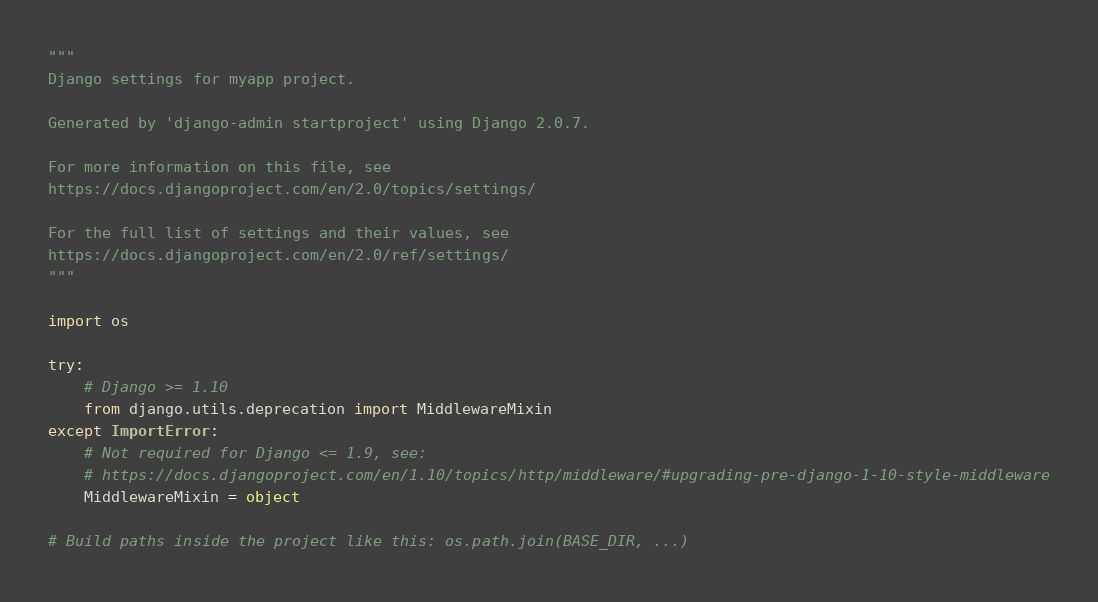Convert code to text. <code><loc_0><loc_0><loc_500><loc_500><_Python_>"""
Django settings for myapp project.

Generated by 'django-admin startproject' using Django 2.0.7.

For more information on this file, see
https://docs.djangoproject.com/en/2.0/topics/settings/

For the full list of settings and their values, see
https://docs.djangoproject.com/en/2.0/ref/settings/
"""

import os

try:
    # Django >= 1.10
    from django.utils.deprecation import MiddlewareMixin
except ImportError:
    # Not required for Django <= 1.9, see:
    # https://docs.djangoproject.com/en/1.10/topics/http/middleware/#upgrading-pre-django-1-10-style-middleware
    MiddlewareMixin = object

# Build paths inside the project like this: os.path.join(BASE_DIR, ...)</code> 